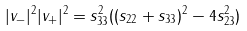<formula> <loc_0><loc_0><loc_500><loc_500>| v _ { - } | ^ { 2 } | v _ { + } | ^ { 2 } = s _ { 3 3 } ^ { 2 } ( ( s _ { 2 2 } + s _ { 3 3 } ) ^ { 2 } - 4 s _ { 2 3 } ^ { 2 } )</formula> 